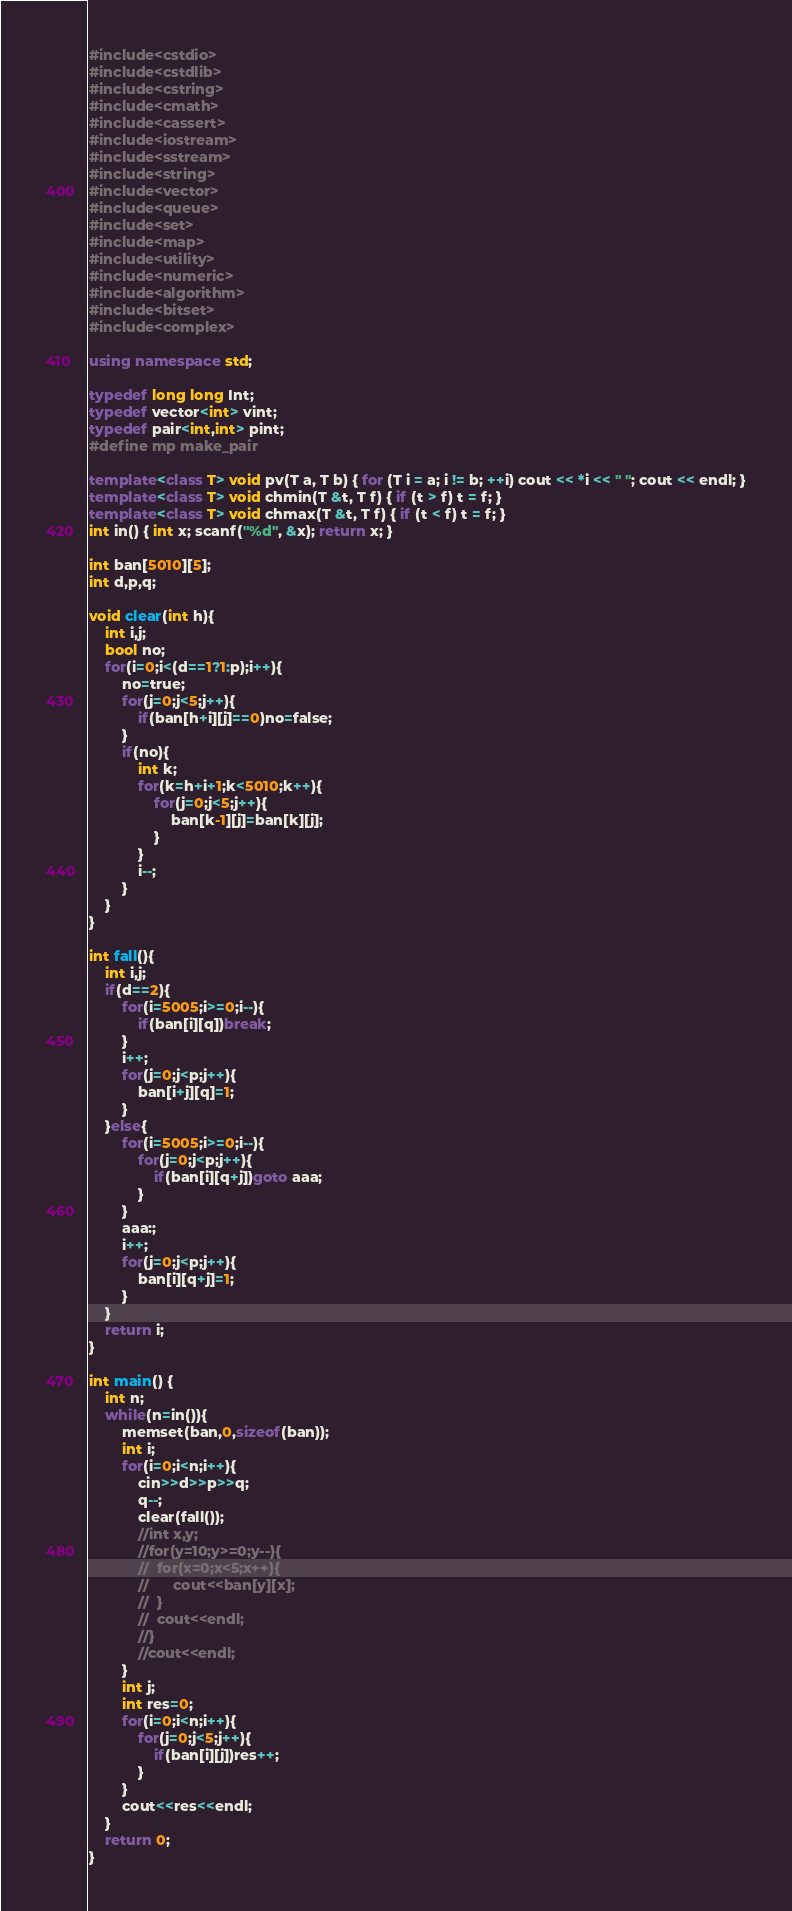Convert code to text. <code><loc_0><loc_0><loc_500><loc_500><_C++_>#include<cstdio>
#include<cstdlib>
#include<cstring>
#include<cmath>
#include<cassert>
#include<iostream>
#include<sstream>
#include<string>
#include<vector>
#include<queue>
#include<set>
#include<map>
#include<utility>
#include<numeric>
#include<algorithm>
#include<bitset>
#include<complex>

using namespace std;

typedef long long Int;
typedef vector<int> vint;
typedef pair<int,int> pint;
#define mp make_pair

template<class T> void pv(T a, T b) { for (T i = a; i != b; ++i) cout << *i << " "; cout << endl; }
template<class T> void chmin(T &t, T f) { if (t > f) t = f; }
template<class T> void chmax(T &t, T f) { if (t < f) t = f; }
int in() { int x; scanf("%d", &x); return x; }

int ban[5010][5];
int d,p,q;

void clear(int h){
	int i,j;
	bool no;
	for(i=0;i<(d==1?1:p);i++){
		no=true;
		for(j=0;j<5;j++){
			if(ban[h+i][j]==0)no=false;
		}
		if(no){
			int k;
			for(k=h+i+1;k<5010;k++){
				for(j=0;j<5;j++){
					ban[k-1][j]=ban[k][j];
				}
			}
			i--;
		}
	}
}

int fall(){
	int i,j;
	if(d==2){
		for(i=5005;i>=0;i--){
			if(ban[i][q])break;
		}
		i++;
		for(j=0;j<p;j++){
			ban[i+j][q]=1;
		}
	}else{
		for(i=5005;i>=0;i--){
			for(j=0;j<p;j++){
				if(ban[i][q+j])goto aaa;
			}
		}
		aaa:;
		i++;
		for(j=0;j<p;j++){
			ban[i][q+j]=1;
		}		
	}
	return i;
}

int main() {
	int n;
	while(n=in()){
		memset(ban,0,sizeof(ban));
		int i;
		for(i=0;i<n;i++){
			cin>>d>>p>>q;
			q--;
			clear(fall());
			//int x,y;
			//for(y=10;y>=0;y--){
			//	for(x=0;x<5;x++){
			//		cout<<ban[y][x];
			//	}
			//	cout<<endl;
			//}
			//cout<<endl;
		}
		int j;
		int res=0;
		for(i=0;i<n;i++){
			for(j=0;j<5;j++){
				if(ban[i][j])res++;
			}
		}
		cout<<res<<endl;
	}
	return 0;
}</code> 